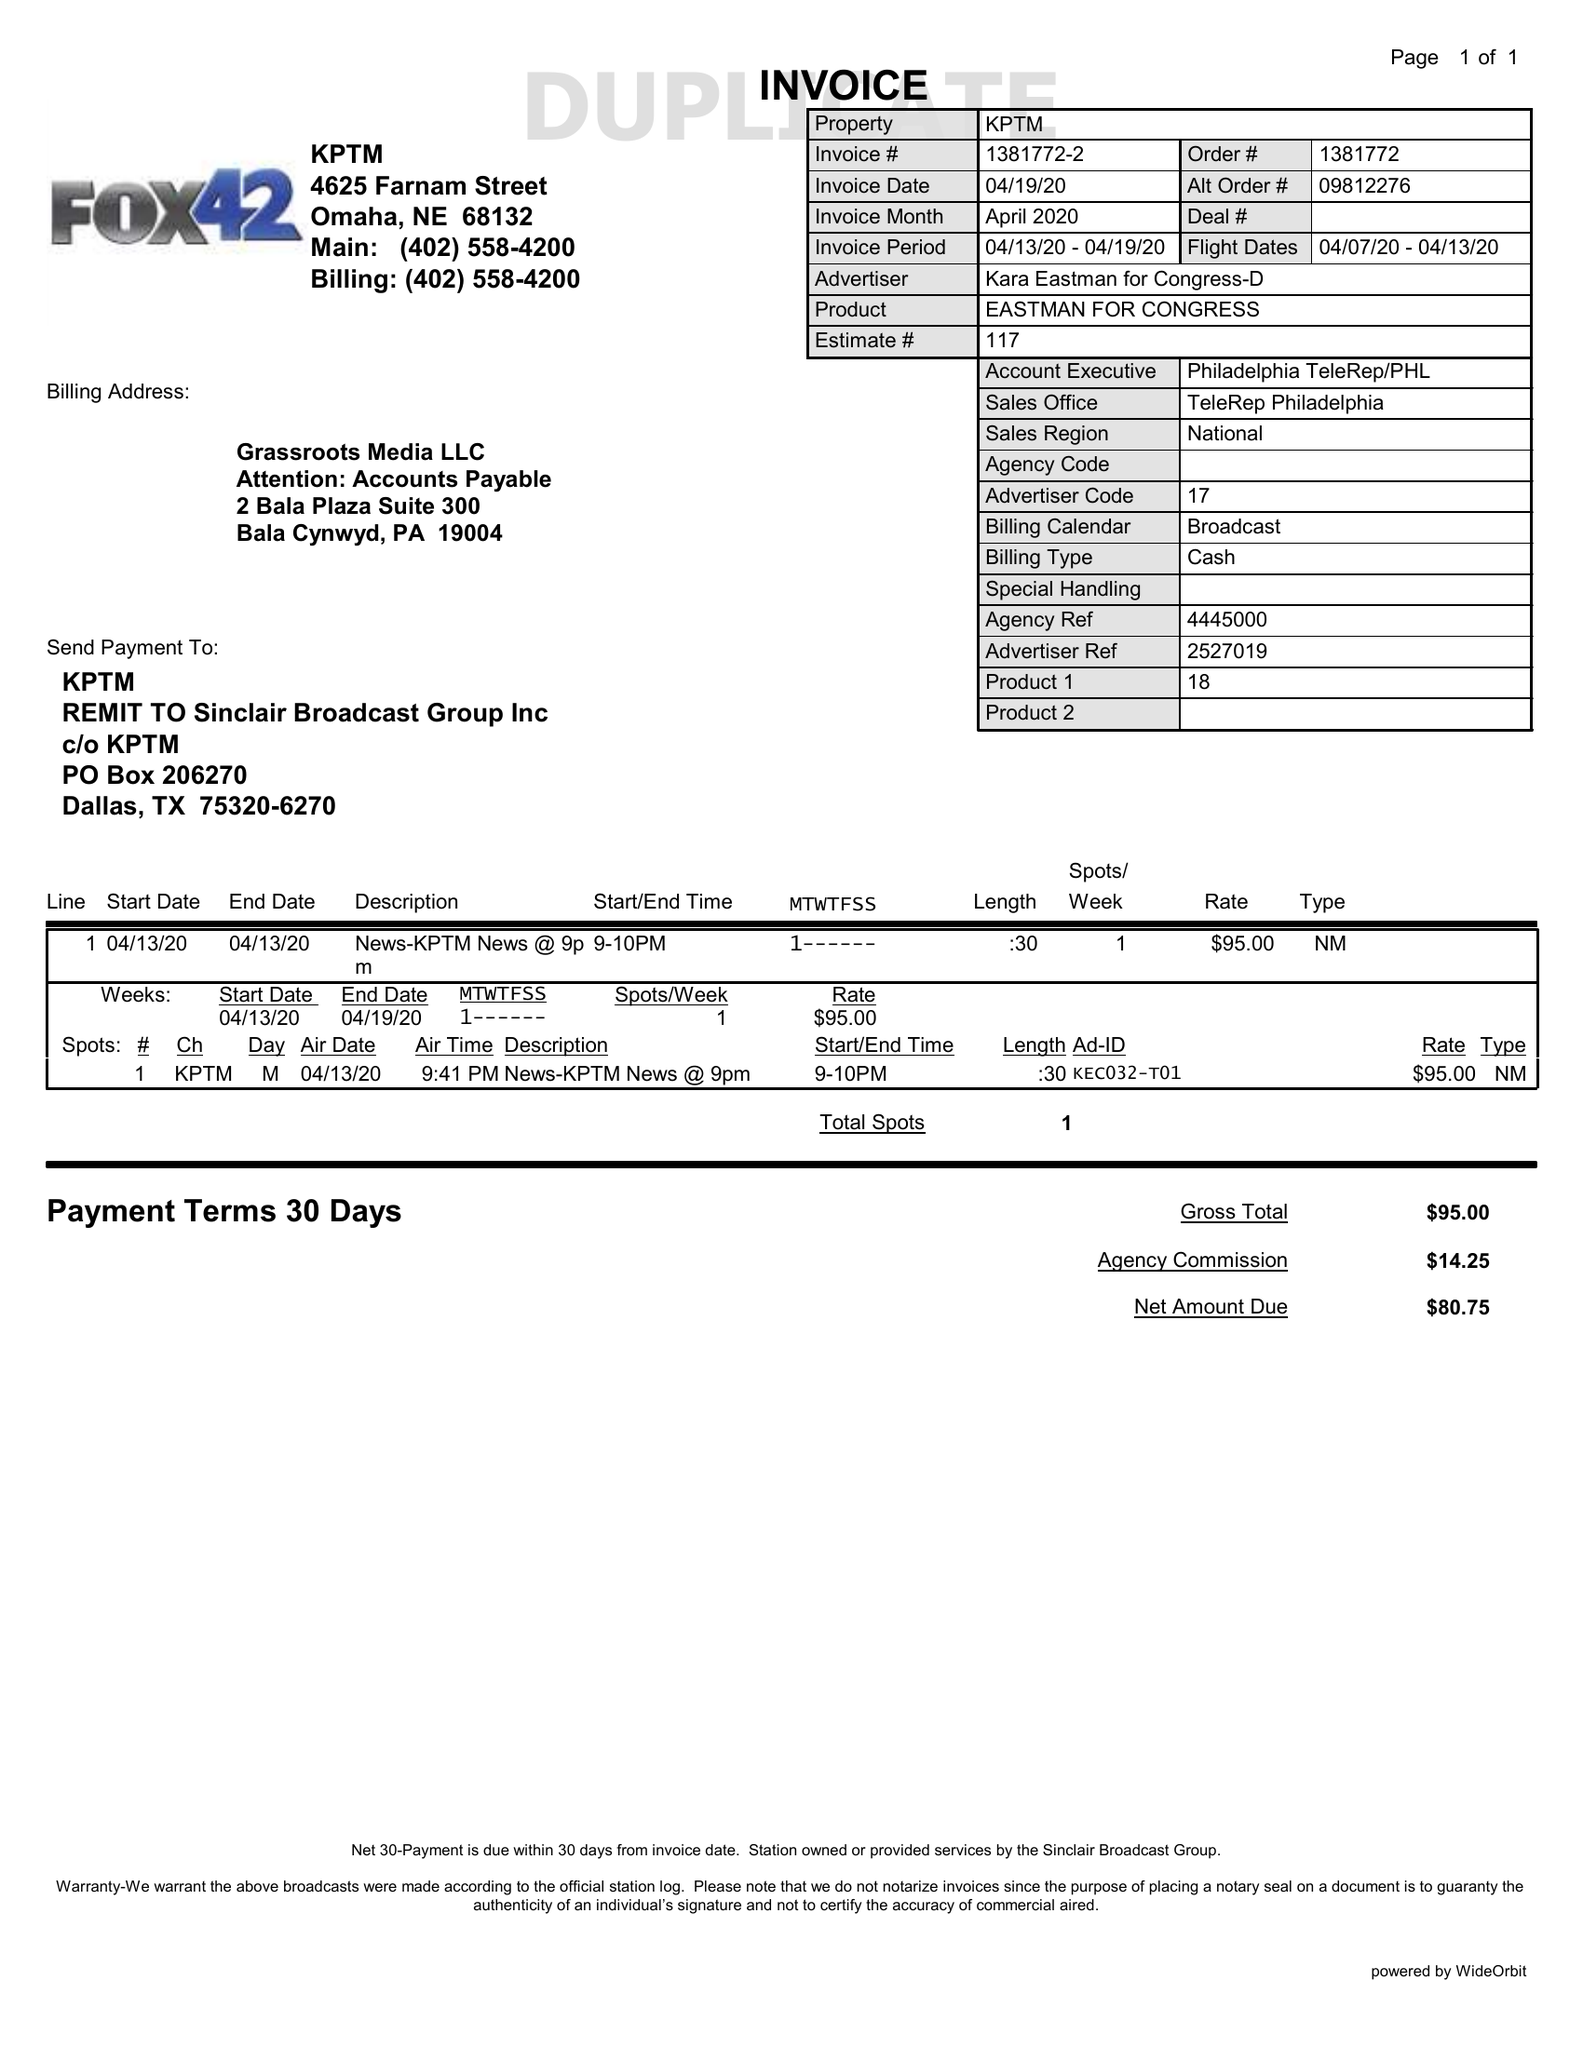What is the value for the contract_num?
Answer the question using a single word or phrase. 1381772 